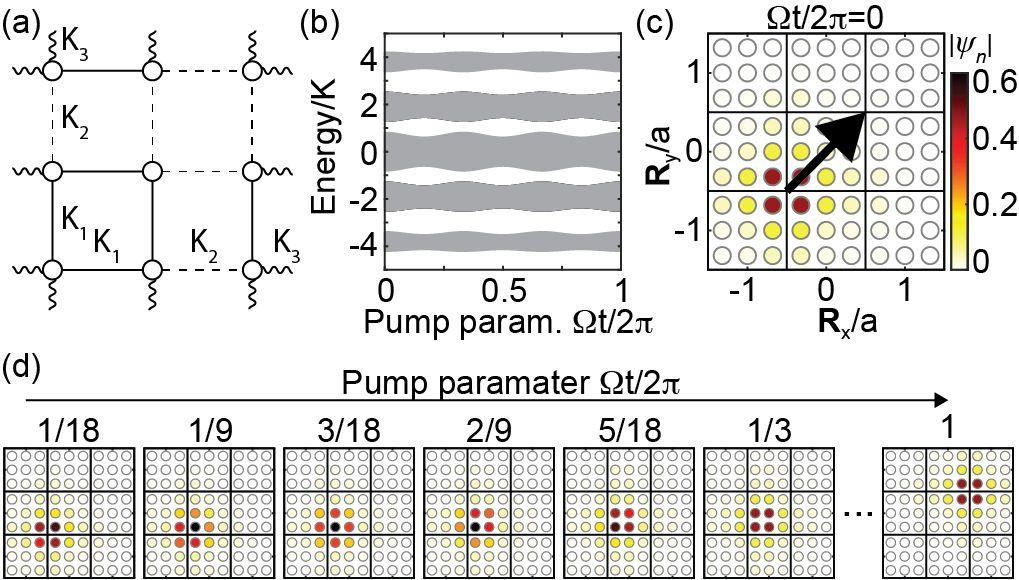What does the circular plot in Subfigure (c) signify? Subfigure (c) presents a radial plot where the color intensity indicates the absolute value of \\(\\psi\\no). The axes labeled as \\(R_y/a\\no) and \\(R_x/a\\no) suggest a coordinate system, probably depicting spatial distribution. The circular plot is used to visualize data in a polar coordinate system, showing how \\(\\psi\\no) changes over different radial positions and directions, highlighted by the arrow and color differences. Can you explain the significance of the color gradient? Certainly! The color gradient in this plot ranges from red to yellow, with red indicating higher values of \\(|\\psi|\\no) and yellow showing lower values. This visualization technique helps in quickly identifying areas with maximum and minimum values of \\(|\\psi|\\no), thus providing insights into which regions have higher or lower amplitude, which is crucial for understanding the physical properties being analyzed. 